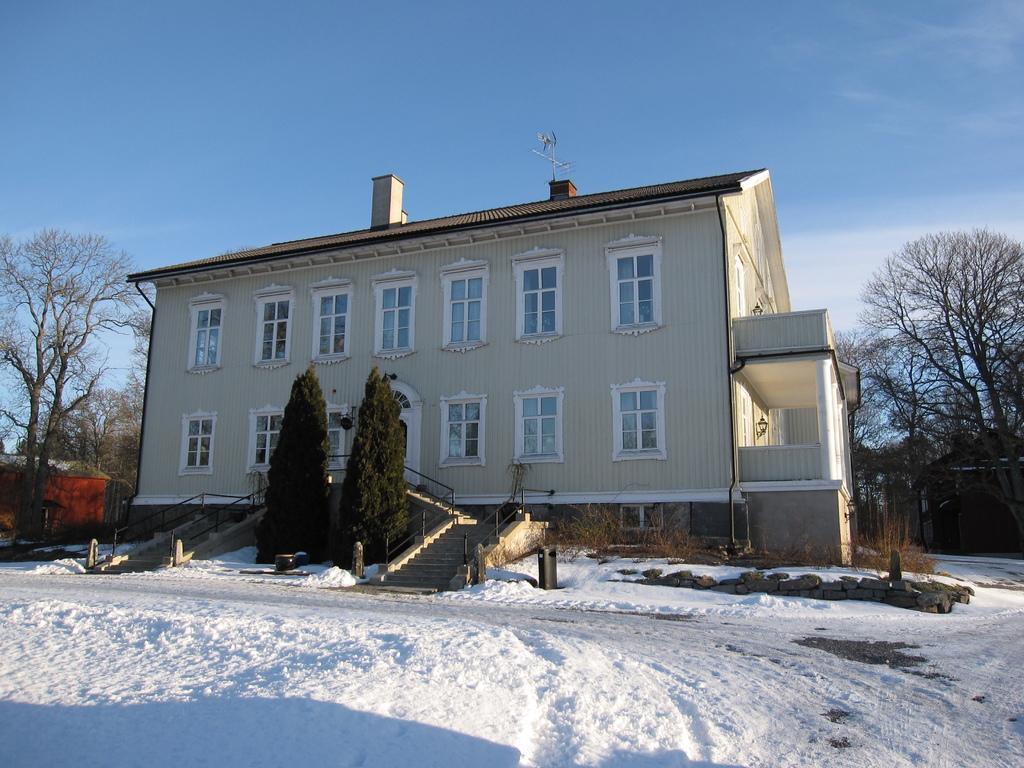Could you give a brief overview of what you see in this image? This is an outside view. At the bottom, I can see the snow. In the middle of the image there is a building. In front of this building, I can see the stairs, few plants and trees. On the right and left sides of the image I can see few trees and houses. At the top of the image as I can see the sky. 